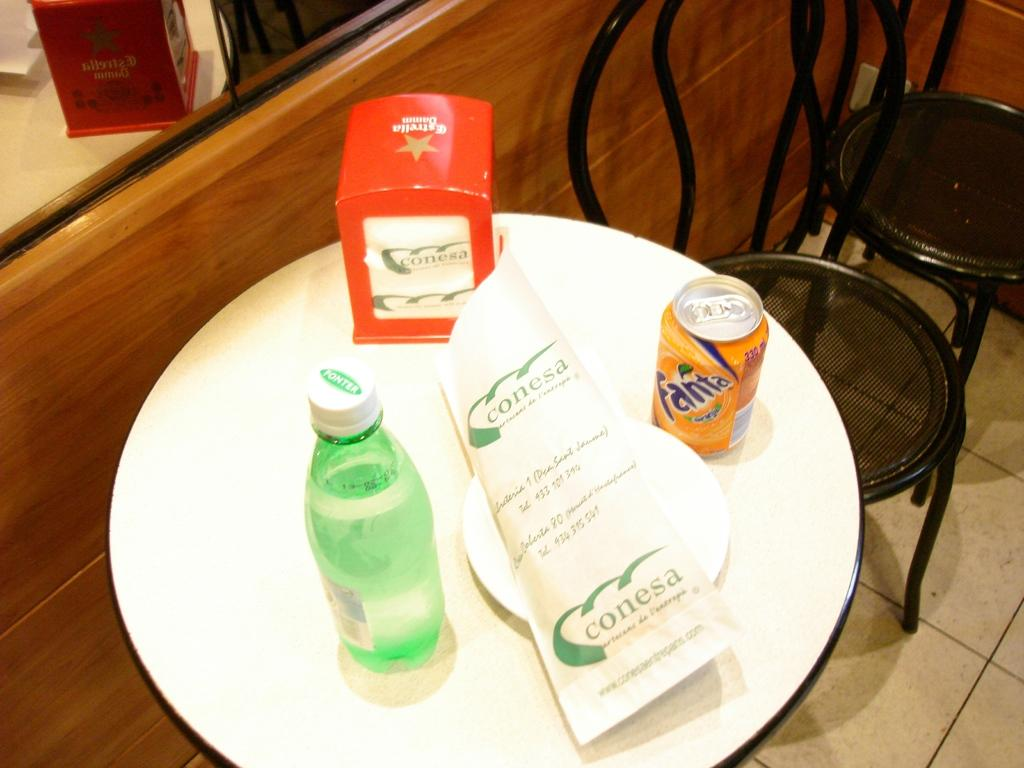<image>
Present a compact description of the photo's key features. the name Fanta is on the soda that is on the white plate 